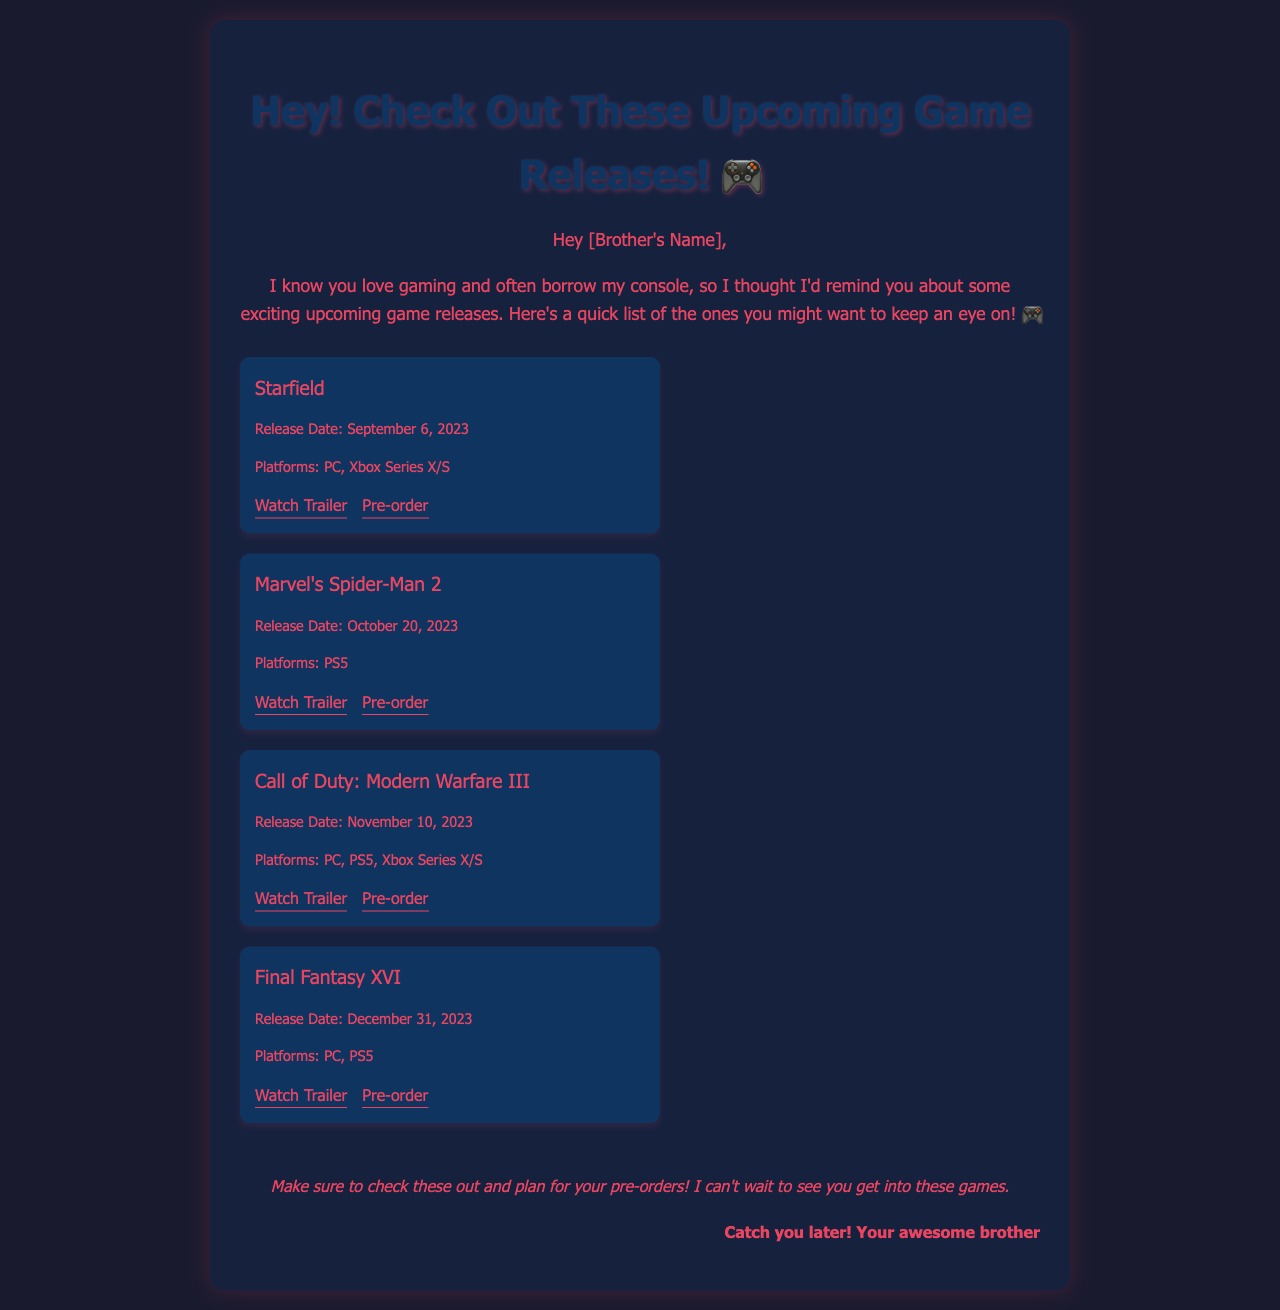What is the release date of Starfield? The release date for Starfield is specifically mentioned in the document, which is September 6, 2023.
Answer: September 6, 2023 Which platforms is Marvel's Spider-Man 2 available on? The document provides information on the platforms for Marvel's Spider-Man 2, which includes PS5.
Answer: PS5 What is the release date of Call of Duty: Modern Warfare III? The document lists the release date for Call of Duty: Modern Warfare III as November 10, 2023.
Answer: November 10, 2023 What game is releasing on October 20, 2023? The document mentions the specific title of the game scheduled for release on October 20, 2023, which is Marvel's Spider-Man 2.
Answer: Marvel's Spider-Man 2 How many games are listed in the document? The document contains a total of four game titles provided in the game list section.
Answer: Four What is the title of the last game mentioned in the email? The last game listed in the document is Final Fantasy XVI, which is specifically mentioned in the game list.
Answer: Final Fantasy XVI What does the sender suggest at the end of the email? The closing section of the email encourages the recipient to check out the games and plan for pre-orders.
Answer: Check these out and plan for your pre-orders Who is the email addressed to? The introduction of the email indicates that it is addressed to the brother, as it mentions "[Brother's Name]".
Answer: [Brother's Name] 